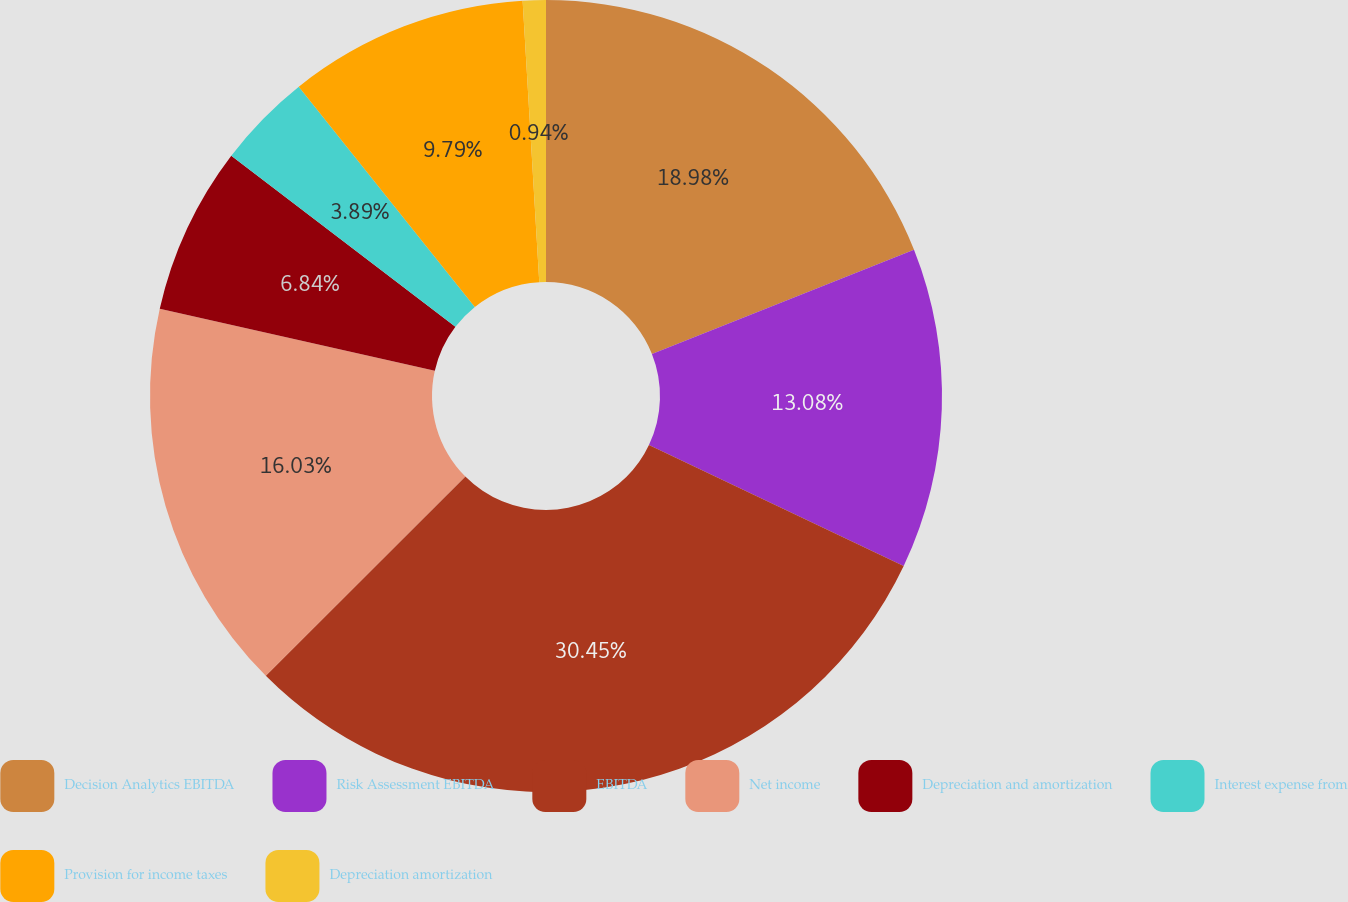Convert chart to OTSL. <chart><loc_0><loc_0><loc_500><loc_500><pie_chart><fcel>Decision Analytics EBITDA<fcel>Risk Assessment EBITDA<fcel>EBITDA<fcel>Net income<fcel>Depreciation and amortization<fcel>Interest expense from<fcel>Provision for income taxes<fcel>Depreciation amortization<nl><fcel>18.98%<fcel>13.08%<fcel>30.45%<fcel>16.03%<fcel>6.84%<fcel>3.89%<fcel>9.79%<fcel>0.94%<nl></chart> 